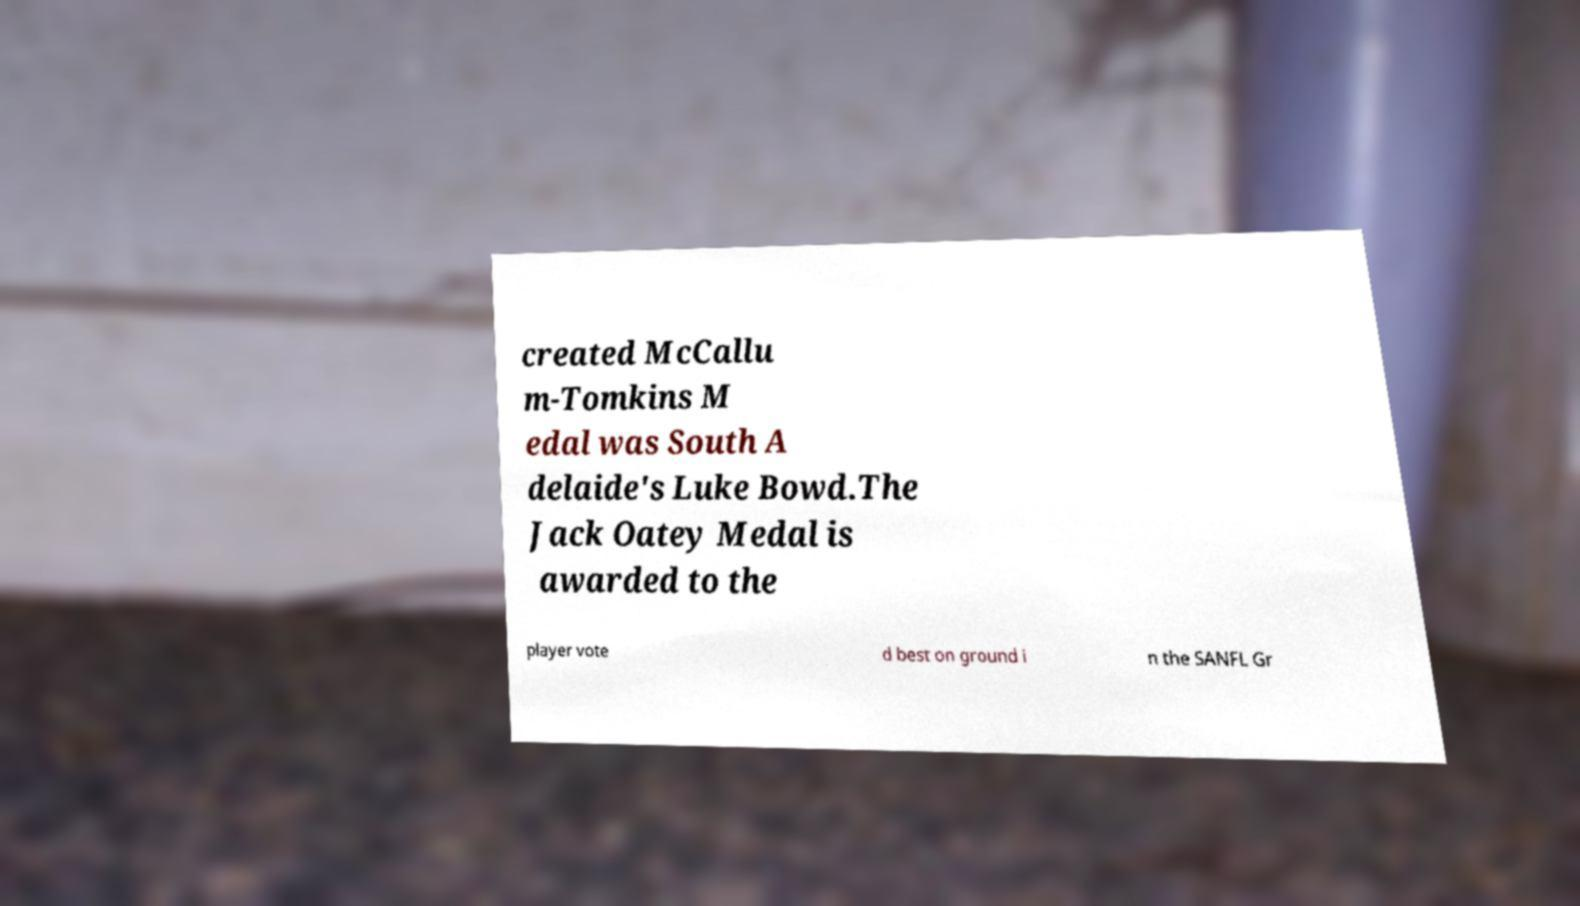Could you assist in decoding the text presented in this image and type it out clearly? created McCallu m-Tomkins M edal was South A delaide's Luke Bowd.The Jack Oatey Medal is awarded to the player vote d best on ground i n the SANFL Gr 